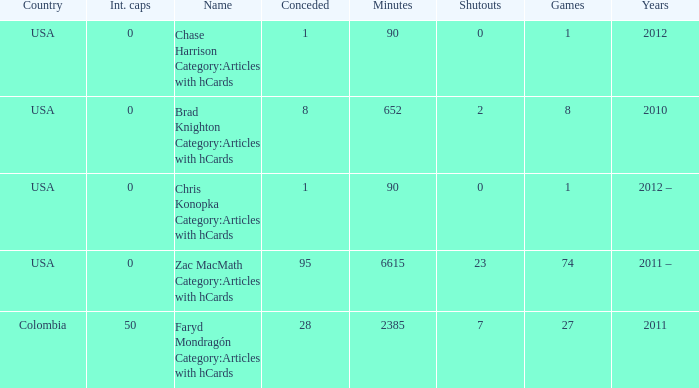What is the lowest overall amount of shutouts? 0.0. 